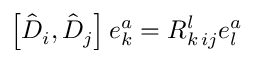<formula> <loc_0><loc_0><loc_500><loc_500>\left [ \hat { D } _ { i } , \hat { D } _ { j } \right ] e _ { k } ^ { a } = R _ { k \, i j } ^ { l } e _ { l } ^ { a }</formula> 